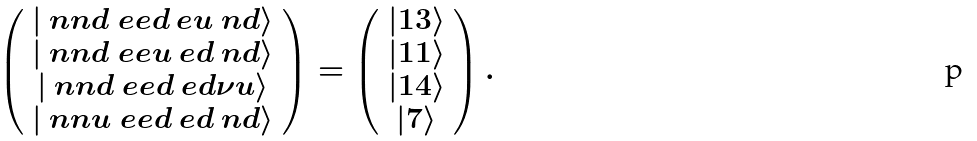Convert formula to latex. <formula><loc_0><loc_0><loc_500><loc_500>\left ( \begin{array} { c } | \ n n d \ e e d \ e u \ n d \rangle \\ | \ n n d \ e e u \ e d \ n d \rangle \\ | \ n n d \ e e d \ e d \nu u \rangle \\ | \ n n u \ e e d \ e d \ n d \rangle \\ \end{array} \right ) = \left ( \begin{array} { c } | 1 3 \rangle \\ | 1 1 \rangle \\ | 1 4 \rangle \\ | 7 \rangle \\ \end{array} \right ) .</formula> 